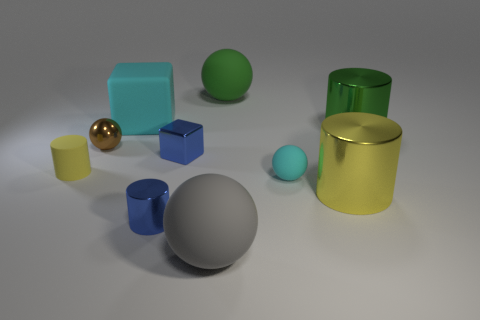How many objects in the image have reflective surfaces? There are three objects with reflective surfaces in the image. The gold sphere, the green cylinder, and the gold cylinder have surfaces that show clear reflections and highlights. 